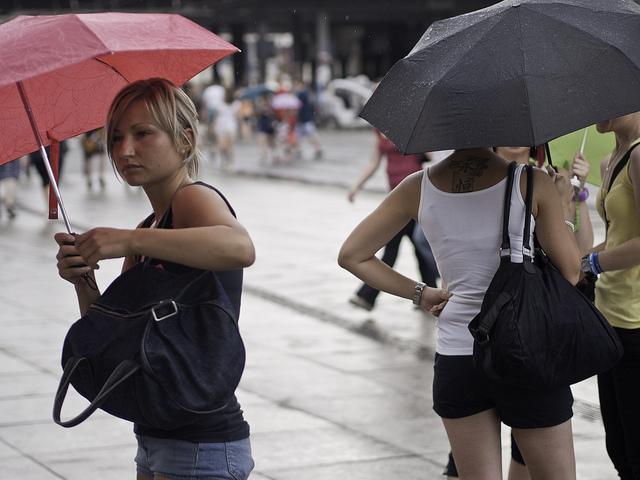What color is the handle in the girl's hand?
Quick response, please. Black. How many people?
Keep it brief. 3. Is this image mostly in black and white?
Give a very brief answer. No. Are all the people wearing shorts?
Be succinct. No. How many bracelets is the woman wearing?
Be succinct. 0. How many umbrellas are there?
Answer briefly. 2. What type of garment is the woman wearing?
Answer briefly. Shorts. Are these girls friends?
Give a very brief answer. No. What is the weather like?
Concise answer only. Rainy. Was it taken in Summer?
Keep it brief. Yes. 